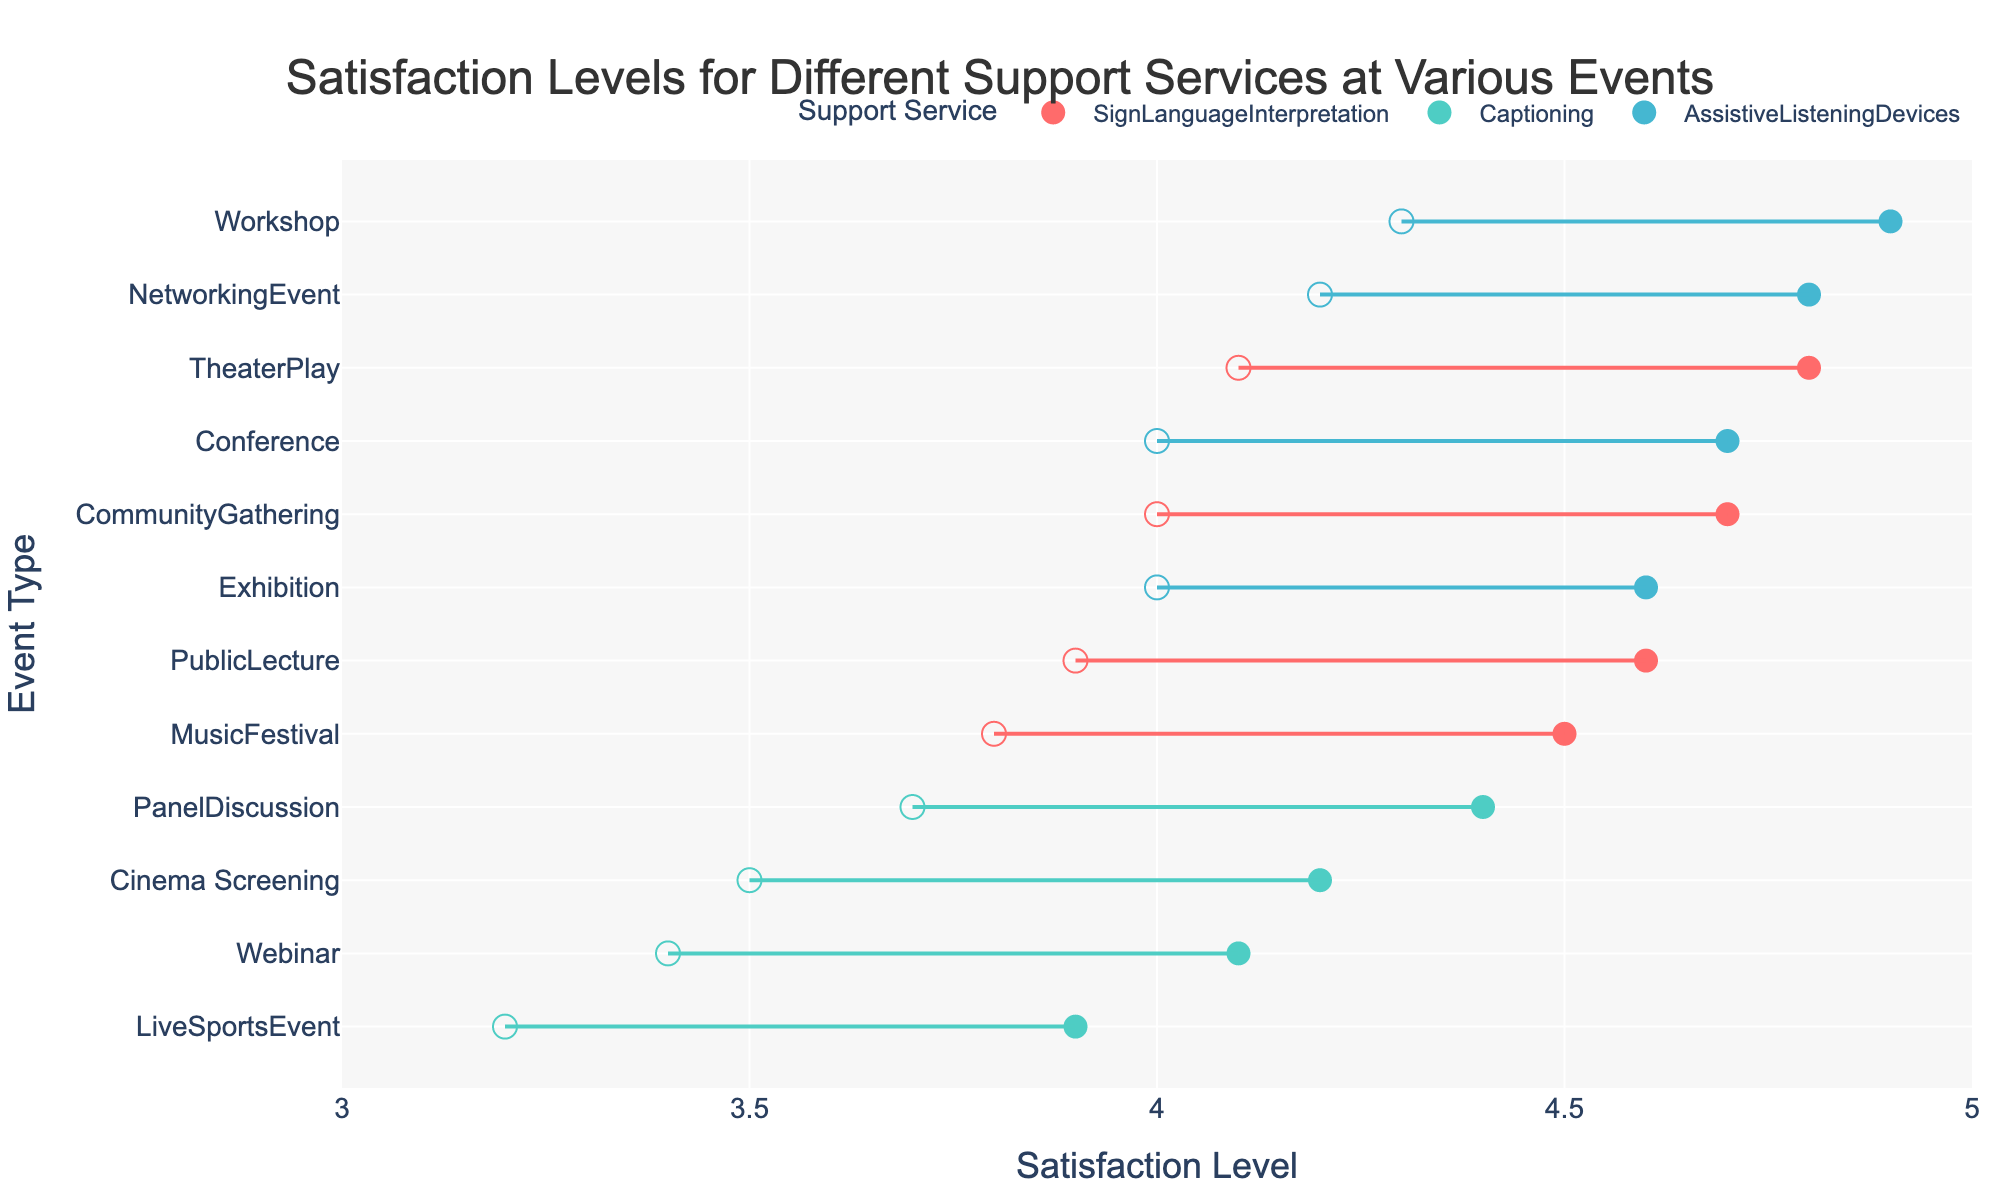What's the title of the plot? The plot title is displayed at the top, usually describing what the visual represents. In this case, it mentions the satisfaction levels for different support services at various events.
Answer: Satisfaction Levels for Different Support Services at Various Events What is the range of satisfaction levels for Sign Language Interpretation at a Theater Play? Look for the dots connected by a line that represents Sign Language Interpretation at Theater Play. The left dot indicates the minimum satisfaction (4.1), and the right dot indicates the maximum satisfaction (4.8).
Answer: 4.1 to 4.8 Which event has the highest maximum satisfaction for Captioning? Identify all events with Captioning and locate the maximum satisfaction levels for each. The highest maximum satisfaction for Captioning is 4.4, associated with the Panel Discussion.
Answer: Panel Discussion What is the difference between the maximum and minimum satisfaction levels for Assistive Listening Devices at a Workshop? Locate the corresponding line for Assistive Listening Devices at Workshop. The minimum value is 4.3, and the maximum value is 4.9. Subtract the minimum from the maximum: 4.9 - 4.3 = 0.6
Answer: 0.6 How do the satisfaction levels for Sign Language Interpretation at a Music Festival compare to Captioning at a Webinar? Compare the two ranges: Sign Language Interpretation at Music Festival has a range of 3.8 to 4.5, and Captioning at Webinar has a range of 3.4 to 4.1. Note the respective minimum and maximum values for comparison.
Answer: Music Festival has higher values Which support service has the widest range of satisfaction levels at a Public Lecture? Review the line lengths for each support service at Public Lecture. Sign Language Interpretation’s line ranges from 3.9 to 4.6, giving a range of 0.7.
Answer: Sign Language Interpretation What is the average minimum satisfaction level for all events with Assistive Listening Devices? Add all the minimum satisfaction levels for events with Assistive Listening Devices (4.0 + 4.3 + 4.0 + 4.2 = 16.5) and divide by the number of events (4). 16.5 / 4 = 4.125
Answer: 4.125 Which event has the smallest range of satisfaction levels overall? Examine the line lengths for all events across services. The shorter the line, the smaller the range. The Cinema Screening with Captioning has the smallest range (3.5 to 4.1), which is 0.6.
Answer: Cinema Screening How many events have a maximum satisfaction level below 4.5? Count the events where the rightmost dot (maximum satisfaction) is below 4.5: Cinema Screening (Captioning), Live Sports Event (Captioning), Webinar (Captioning). There are 3 such events.
Answer: 3 Which support service has the highest minimum satisfaction level at a Networking Event? Look at the data points for the Networking Event. There is only Assistive Listening Devices for this event, with a minimum satisfaction level of 4.2.
Answer: Assistive Listening Devices 